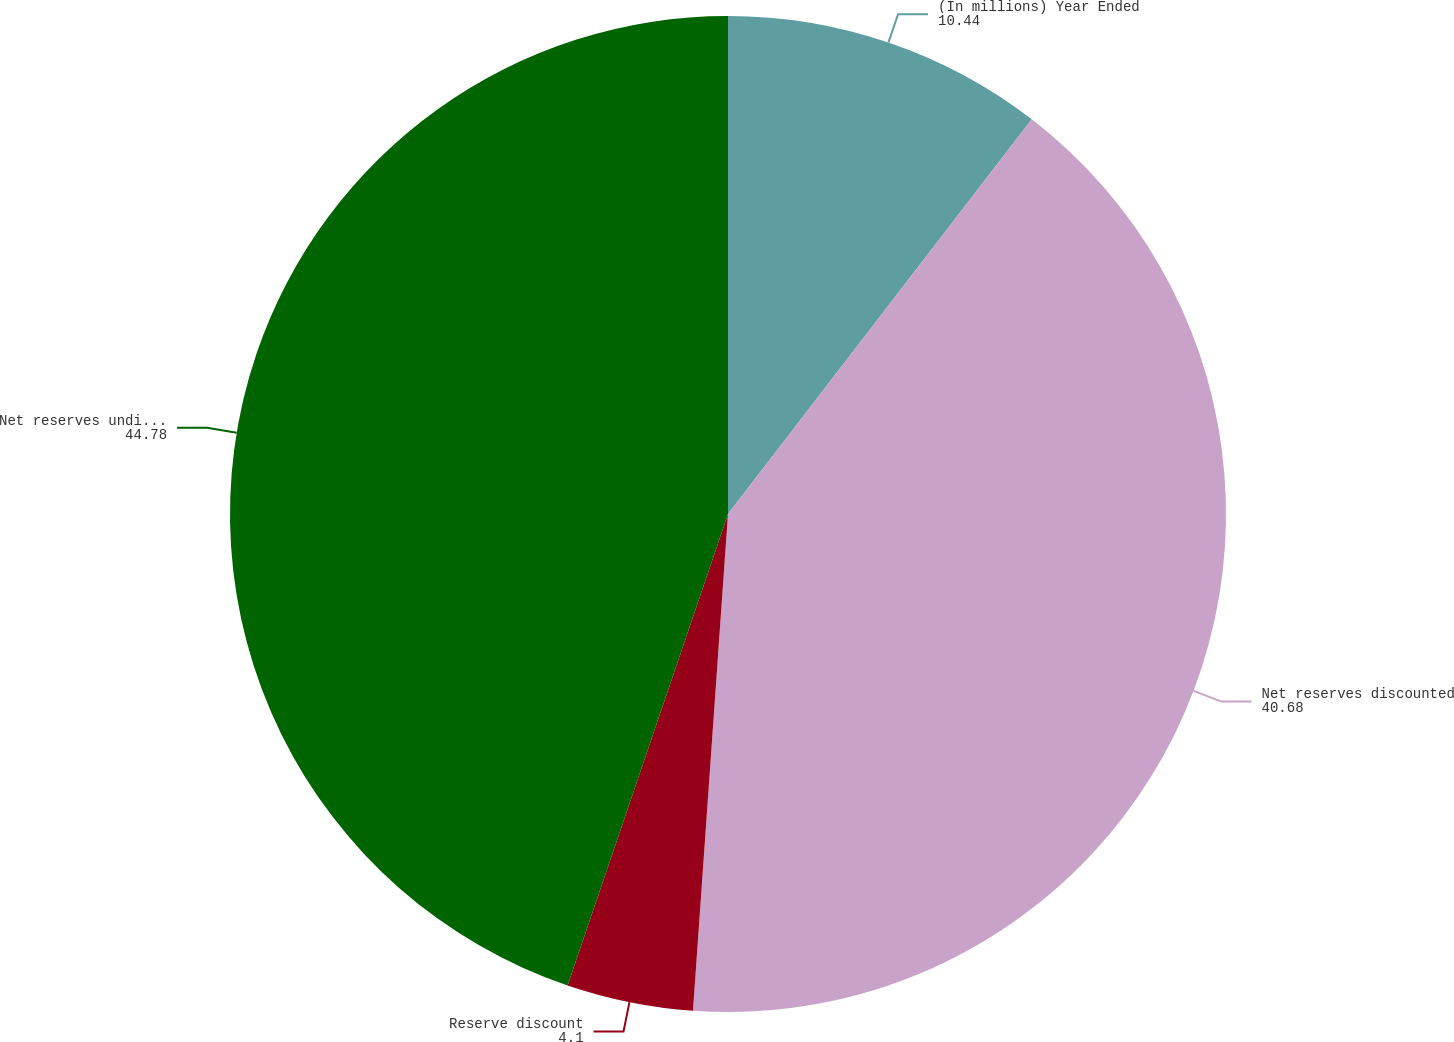<chart> <loc_0><loc_0><loc_500><loc_500><pie_chart><fcel>(In millions) Year Ended<fcel>Net reserves discounted<fcel>Reserve discount<fcel>Net reserves undiscounted<nl><fcel>10.44%<fcel>40.68%<fcel>4.1%<fcel>44.78%<nl></chart> 